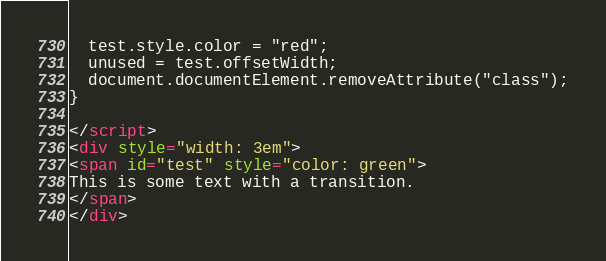Convert code to text. <code><loc_0><loc_0><loc_500><loc_500><_HTML_>  test.style.color = "red";
  unused = test.offsetWidth;
  document.documentElement.removeAttribute("class");
}

</script>
<div style="width: 3em">
<span id="test" style="color: green">
This is some text with a transition.
</span>
</div>
</code> 